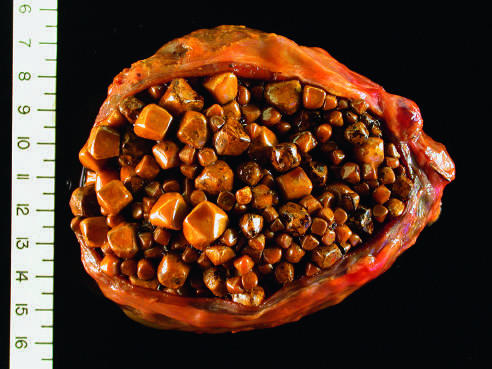s the infant thickened and fibrotic due to chronic cholecystitis?
Answer the question using a single word or phrase. No 